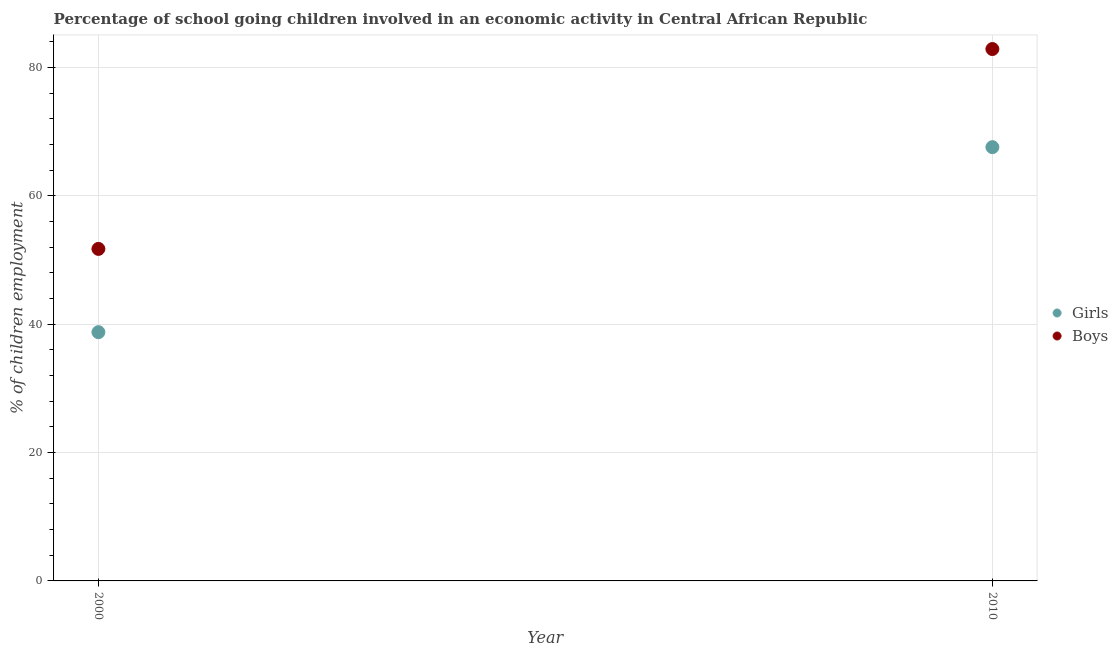How many different coloured dotlines are there?
Provide a short and direct response. 2. What is the percentage of school going girls in 2010?
Provide a short and direct response. 67.58. Across all years, what is the maximum percentage of school going boys?
Keep it short and to the point. 82.87. Across all years, what is the minimum percentage of school going boys?
Keep it short and to the point. 51.73. In which year was the percentage of school going girls maximum?
Provide a succinct answer. 2010. In which year was the percentage of school going girls minimum?
Offer a very short reply. 2000. What is the total percentage of school going girls in the graph?
Offer a very short reply. 106.34. What is the difference between the percentage of school going boys in 2000 and that in 2010?
Provide a short and direct response. -31.14. What is the difference between the percentage of school going girls in 2010 and the percentage of school going boys in 2000?
Make the answer very short. 15.85. What is the average percentage of school going girls per year?
Provide a short and direct response. 53.17. In the year 2010, what is the difference between the percentage of school going boys and percentage of school going girls?
Keep it short and to the point. 15.29. What is the ratio of the percentage of school going boys in 2000 to that in 2010?
Provide a short and direct response. 0.62. Is the percentage of school going boys in 2000 less than that in 2010?
Give a very brief answer. Yes. Are the values on the major ticks of Y-axis written in scientific E-notation?
Your answer should be compact. No. Does the graph contain any zero values?
Make the answer very short. No. Does the graph contain grids?
Provide a short and direct response. Yes. Where does the legend appear in the graph?
Your answer should be compact. Center right. How many legend labels are there?
Keep it short and to the point. 2. What is the title of the graph?
Provide a short and direct response. Percentage of school going children involved in an economic activity in Central African Republic. What is the label or title of the Y-axis?
Provide a short and direct response. % of children employment. What is the % of children employment in Girls in 2000?
Provide a succinct answer. 38.76. What is the % of children employment in Boys in 2000?
Your response must be concise. 51.73. What is the % of children employment of Girls in 2010?
Your answer should be compact. 67.58. What is the % of children employment of Boys in 2010?
Your answer should be compact. 82.87. Across all years, what is the maximum % of children employment in Girls?
Your response must be concise. 67.58. Across all years, what is the maximum % of children employment in Boys?
Make the answer very short. 82.87. Across all years, what is the minimum % of children employment of Girls?
Your answer should be compact. 38.76. Across all years, what is the minimum % of children employment in Boys?
Give a very brief answer. 51.73. What is the total % of children employment in Girls in the graph?
Provide a short and direct response. 106.34. What is the total % of children employment in Boys in the graph?
Make the answer very short. 134.6. What is the difference between the % of children employment of Girls in 2000 and that in 2010?
Offer a terse response. -28.82. What is the difference between the % of children employment in Boys in 2000 and that in 2010?
Offer a terse response. -31.14. What is the difference between the % of children employment of Girls in 2000 and the % of children employment of Boys in 2010?
Make the answer very short. -44.11. What is the average % of children employment in Girls per year?
Your answer should be very brief. 53.17. What is the average % of children employment of Boys per year?
Provide a short and direct response. 67.3. In the year 2000, what is the difference between the % of children employment in Girls and % of children employment in Boys?
Keep it short and to the point. -12.97. In the year 2010, what is the difference between the % of children employment of Girls and % of children employment of Boys?
Offer a very short reply. -15.29. What is the ratio of the % of children employment in Girls in 2000 to that in 2010?
Give a very brief answer. 0.57. What is the ratio of the % of children employment in Boys in 2000 to that in 2010?
Give a very brief answer. 0.62. What is the difference between the highest and the second highest % of children employment of Girls?
Your answer should be compact. 28.82. What is the difference between the highest and the second highest % of children employment of Boys?
Provide a short and direct response. 31.14. What is the difference between the highest and the lowest % of children employment of Girls?
Your answer should be compact. 28.82. What is the difference between the highest and the lowest % of children employment of Boys?
Offer a very short reply. 31.14. 